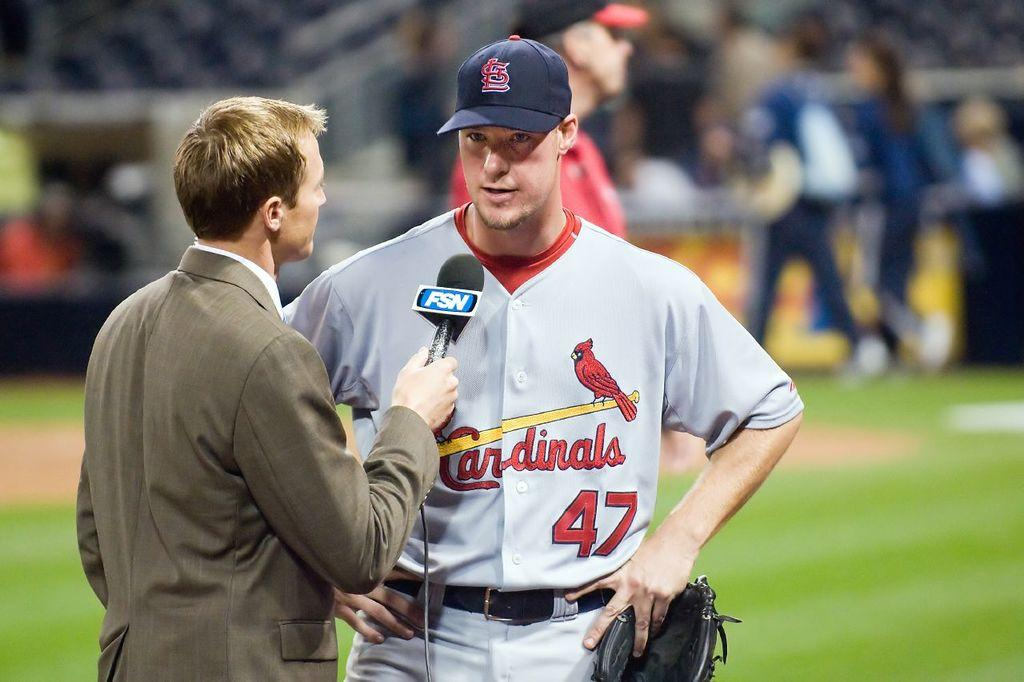<image>
Provide a brief description of the given image. a Cardinals 47 baseball player interviewed on the field 